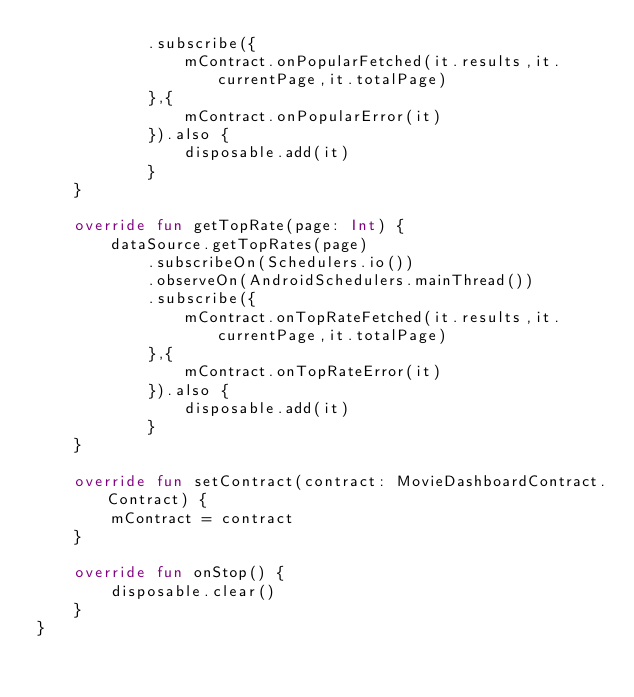<code> <loc_0><loc_0><loc_500><loc_500><_Kotlin_>            .subscribe({
                mContract.onPopularFetched(it.results,it.currentPage,it.totalPage)
            },{
                mContract.onPopularError(it)
            }).also {
                disposable.add(it)
            }
    }

    override fun getTopRate(page: Int) {
        dataSource.getTopRates(page)
            .subscribeOn(Schedulers.io())
            .observeOn(AndroidSchedulers.mainThread())
            .subscribe({
                mContract.onTopRateFetched(it.results,it.currentPage,it.totalPage)
            },{
                mContract.onTopRateError(it)
            }).also {
                disposable.add(it)
            }
    }

    override fun setContract(contract: MovieDashboardContract.Contract) {
        mContract = contract
    }

    override fun onStop() {
        disposable.clear()
    }
}</code> 